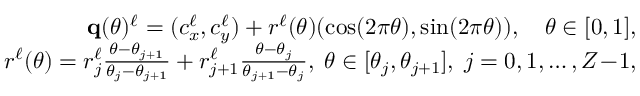Convert formula to latex. <formula><loc_0><loc_0><loc_500><loc_500>\begin{array} { r } { \mathbf q ( \theta ) ^ { \ell } = ( c _ { x } ^ { \ell } , c _ { y } ^ { \ell } ) + r ^ { \ell } ( \theta ) ( \cos ( 2 \pi \theta ) , \sin ( 2 \pi \theta ) ) , \quad \theta \in [ 0 , 1 ] , } \\ { r ^ { \ell } ( \theta ) = r _ { j } ^ { \ell } { \frac { \theta - \theta _ { j + 1 } } { \theta _ { j } - \theta _ { j + 1 } } } + r _ { j + 1 } ^ { \ell } { \frac { \theta - \theta _ { j } } { \theta _ { j + 1 } - \theta _ { j } } } , \, \theta \in [ \theta _ { j } , \theta _ { j + 1 } ] , \, j = 0 , 1 , \dots , Z \, - \, 1 , } \end{array}</formula> 